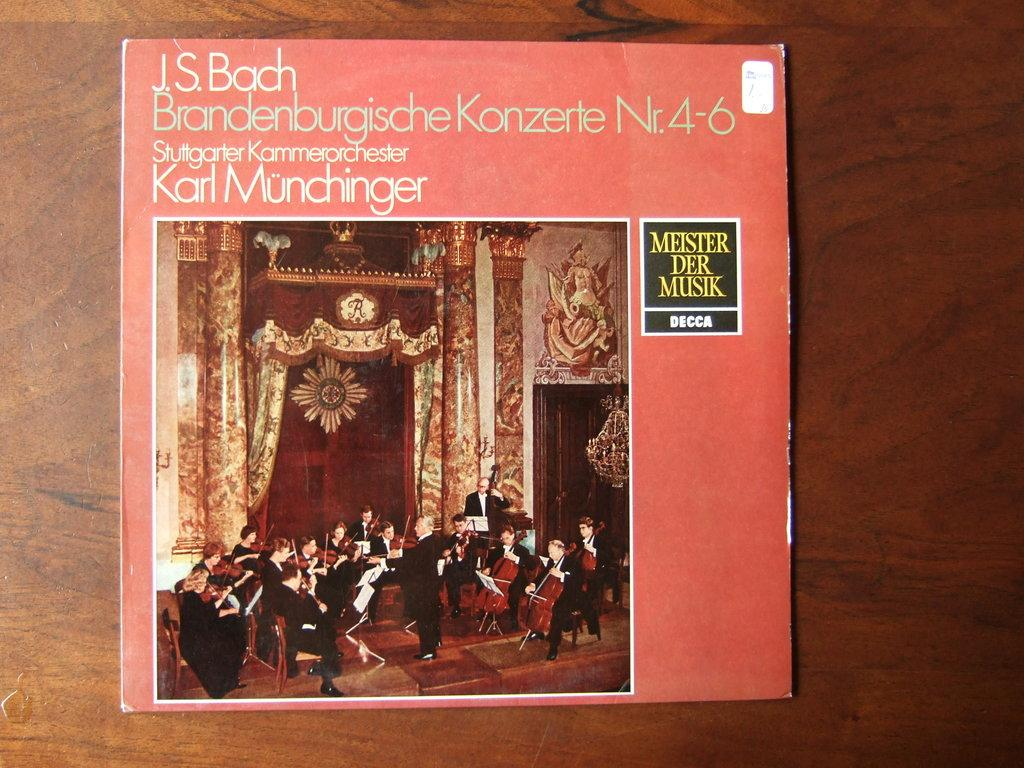<image>
Offer a succinct explanation of the picture presented. J.S. Bach Brandenburgische Konzerte Nr. 4-6 stuttgarter Kammerorchester Karl Munchinger album 